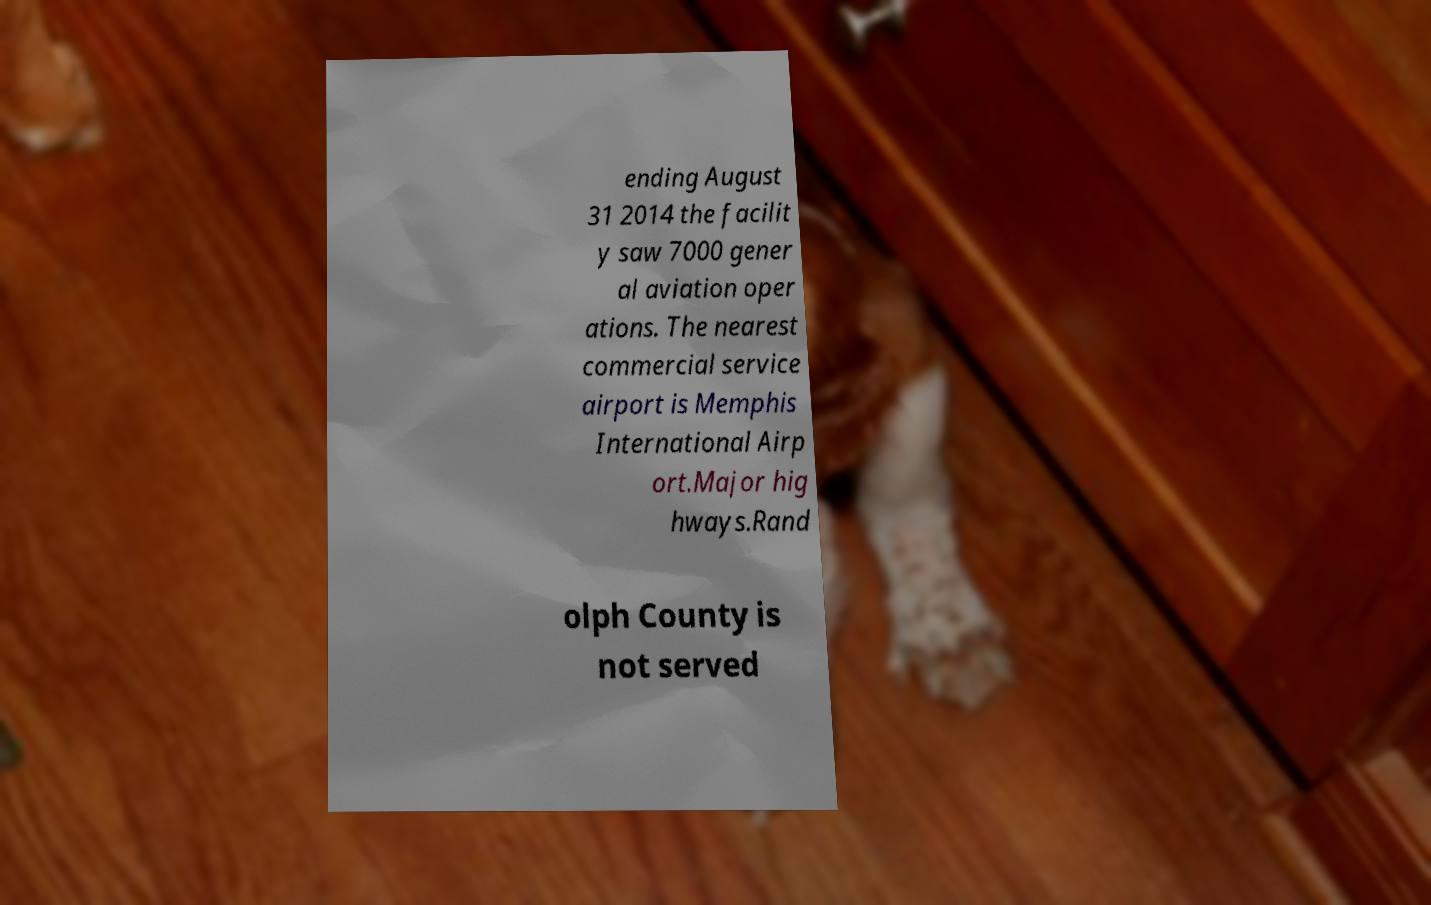Could you assist in decoding the text presented in this image and type it out clearly? ending August 31 2014 the facilit y saw 7000 gener al aviation oper ations. The nearest commercial service airport is Memphis International Airp ort.Major hig hways.Rand olph County is not served 